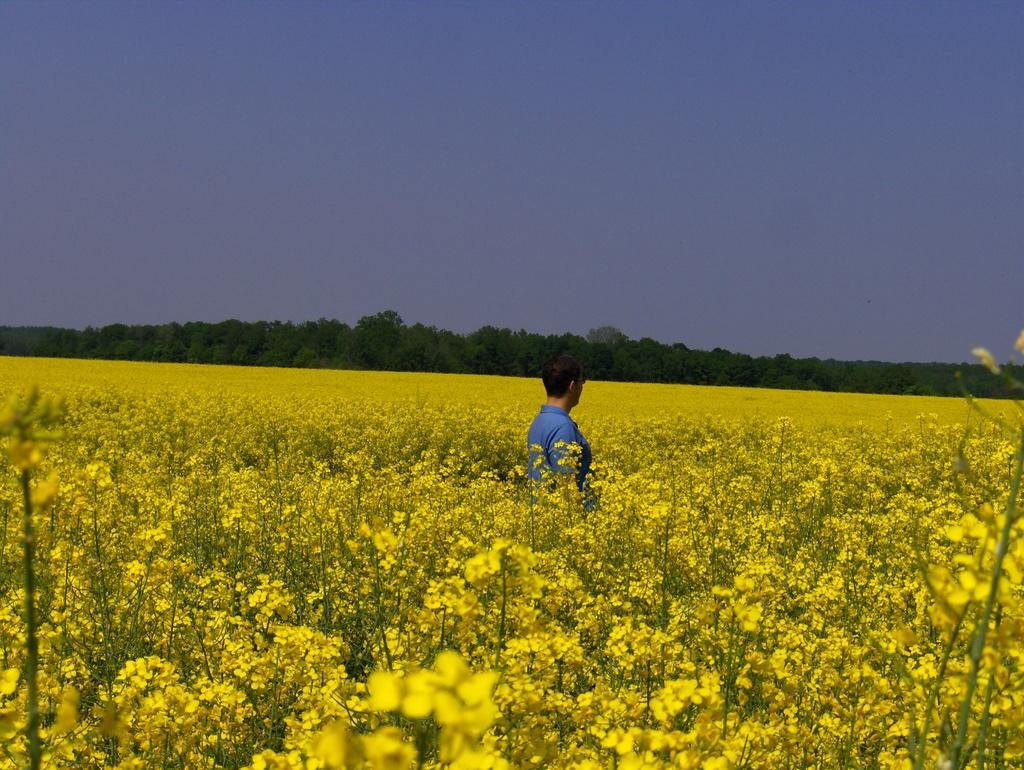What type of garden is shown in the image? There is a canola garden in the image. Is there anyone in the canola garden? Yes, there is a person in the canola garden. What can be seen in the background of the image? There are trees in the background of the image. What type of line can be seen at the airport in the image? There is no airport or line present in the image; it features a canola garden with a person and trees in the background. 